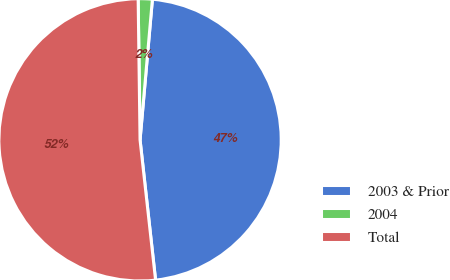Convert chart. <chart><loc_0><loc_0><loc_500><loc_500><pie_chart><fcel>2003 & Prior<fcel>2004<fcel>Total<nl><fcel>46.85%<fcel>1.61%<fcel>51.54%<nl></chart> 